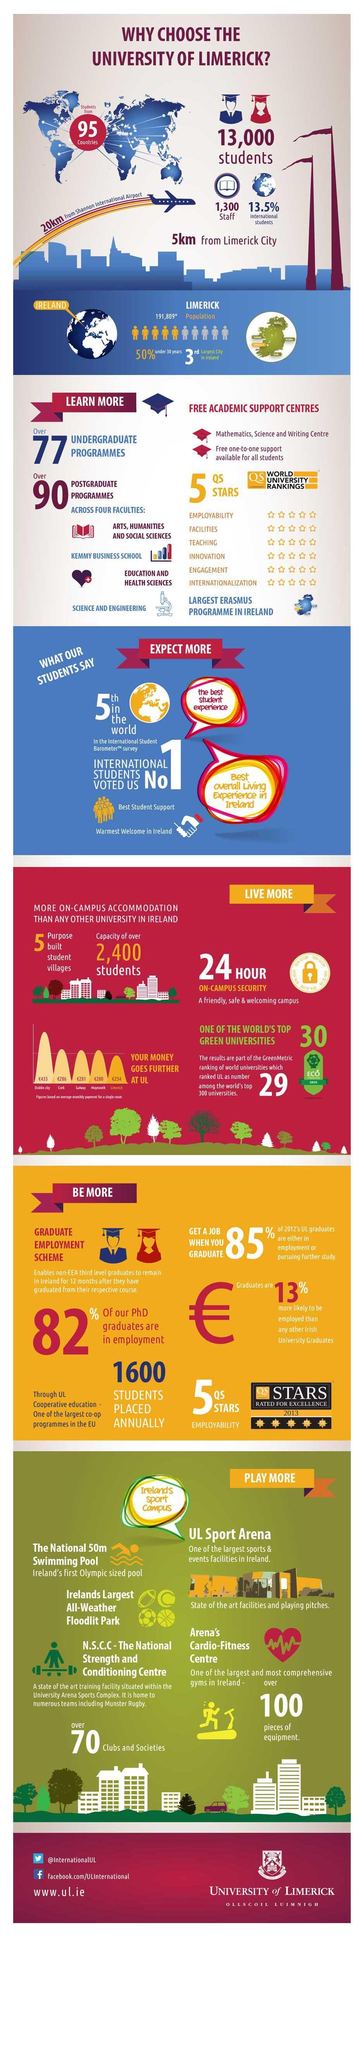What is the distance between Shannon International Airport & University of Limerick?
Answer the question with a short phrase. 20km What is the GreenMetric World University ranking given to University of Limerick? 29 What percentage of international students are studying in University of Limerick? 13.5% What is the world university ranking of University of Limerick? 5 QS STARS How far is University of Limerick from Limerick City? 5km What percentage of PhD graduates in University of Limerick are employed? 82% What is the number of staffs working in University of Limerick? 1,300 What is the number of students in University of Limerick? 13,000 